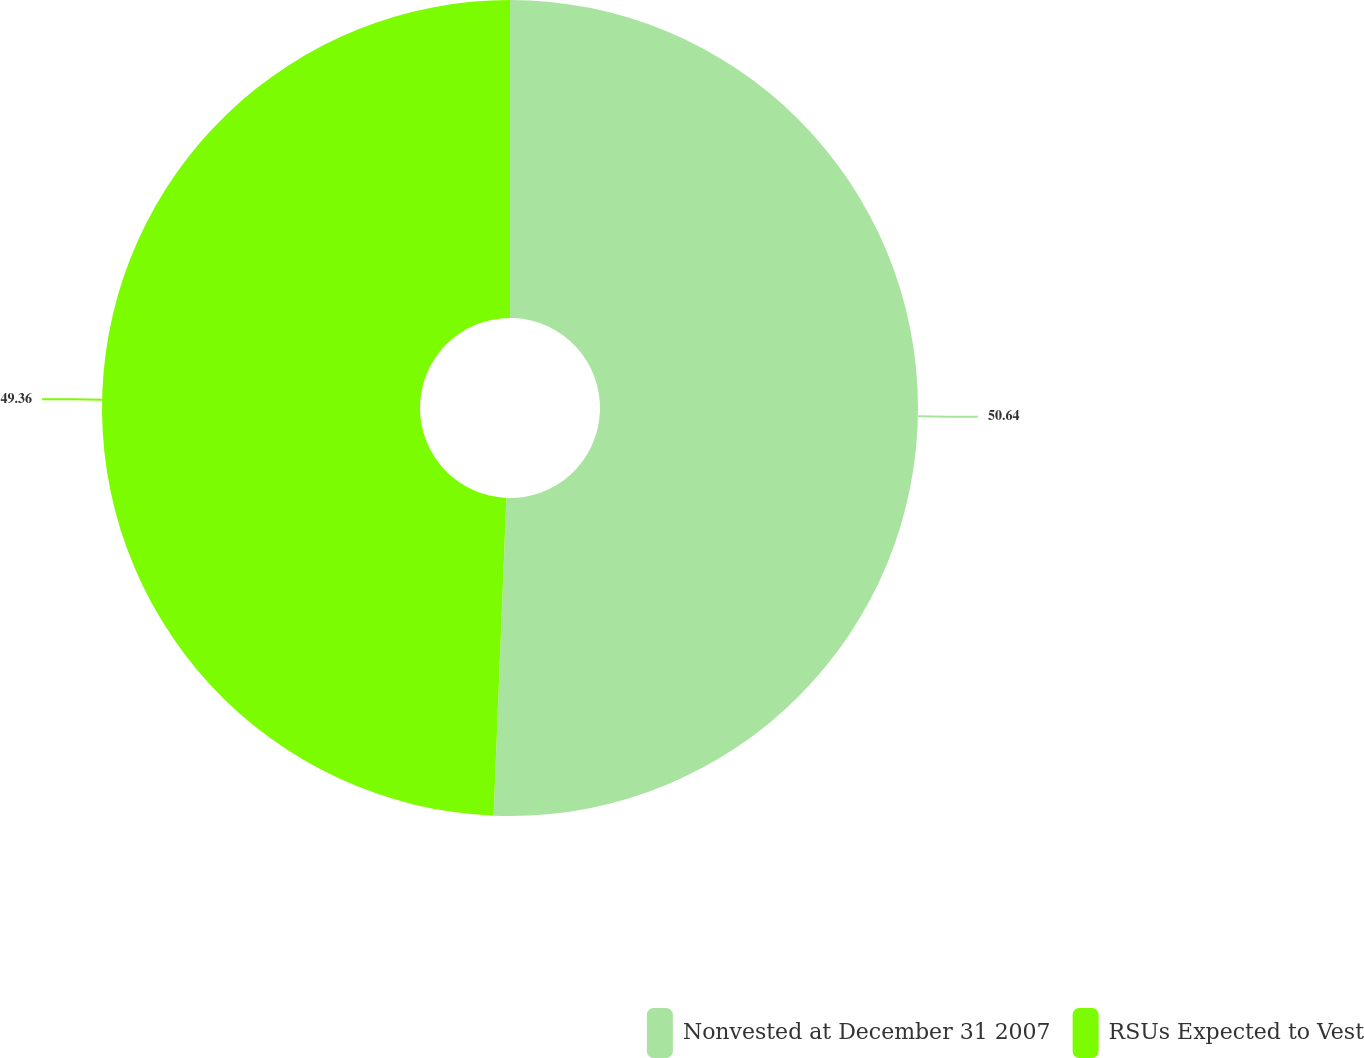<chart> <loc_0><loc_0><loc_500><loc_500><pie_chart><fcel>Nonvested at December 31 2007<fcel>RSUs Expected to Vest<nl><fcel>50.64%<fcel>49.36%<nl></chart> 